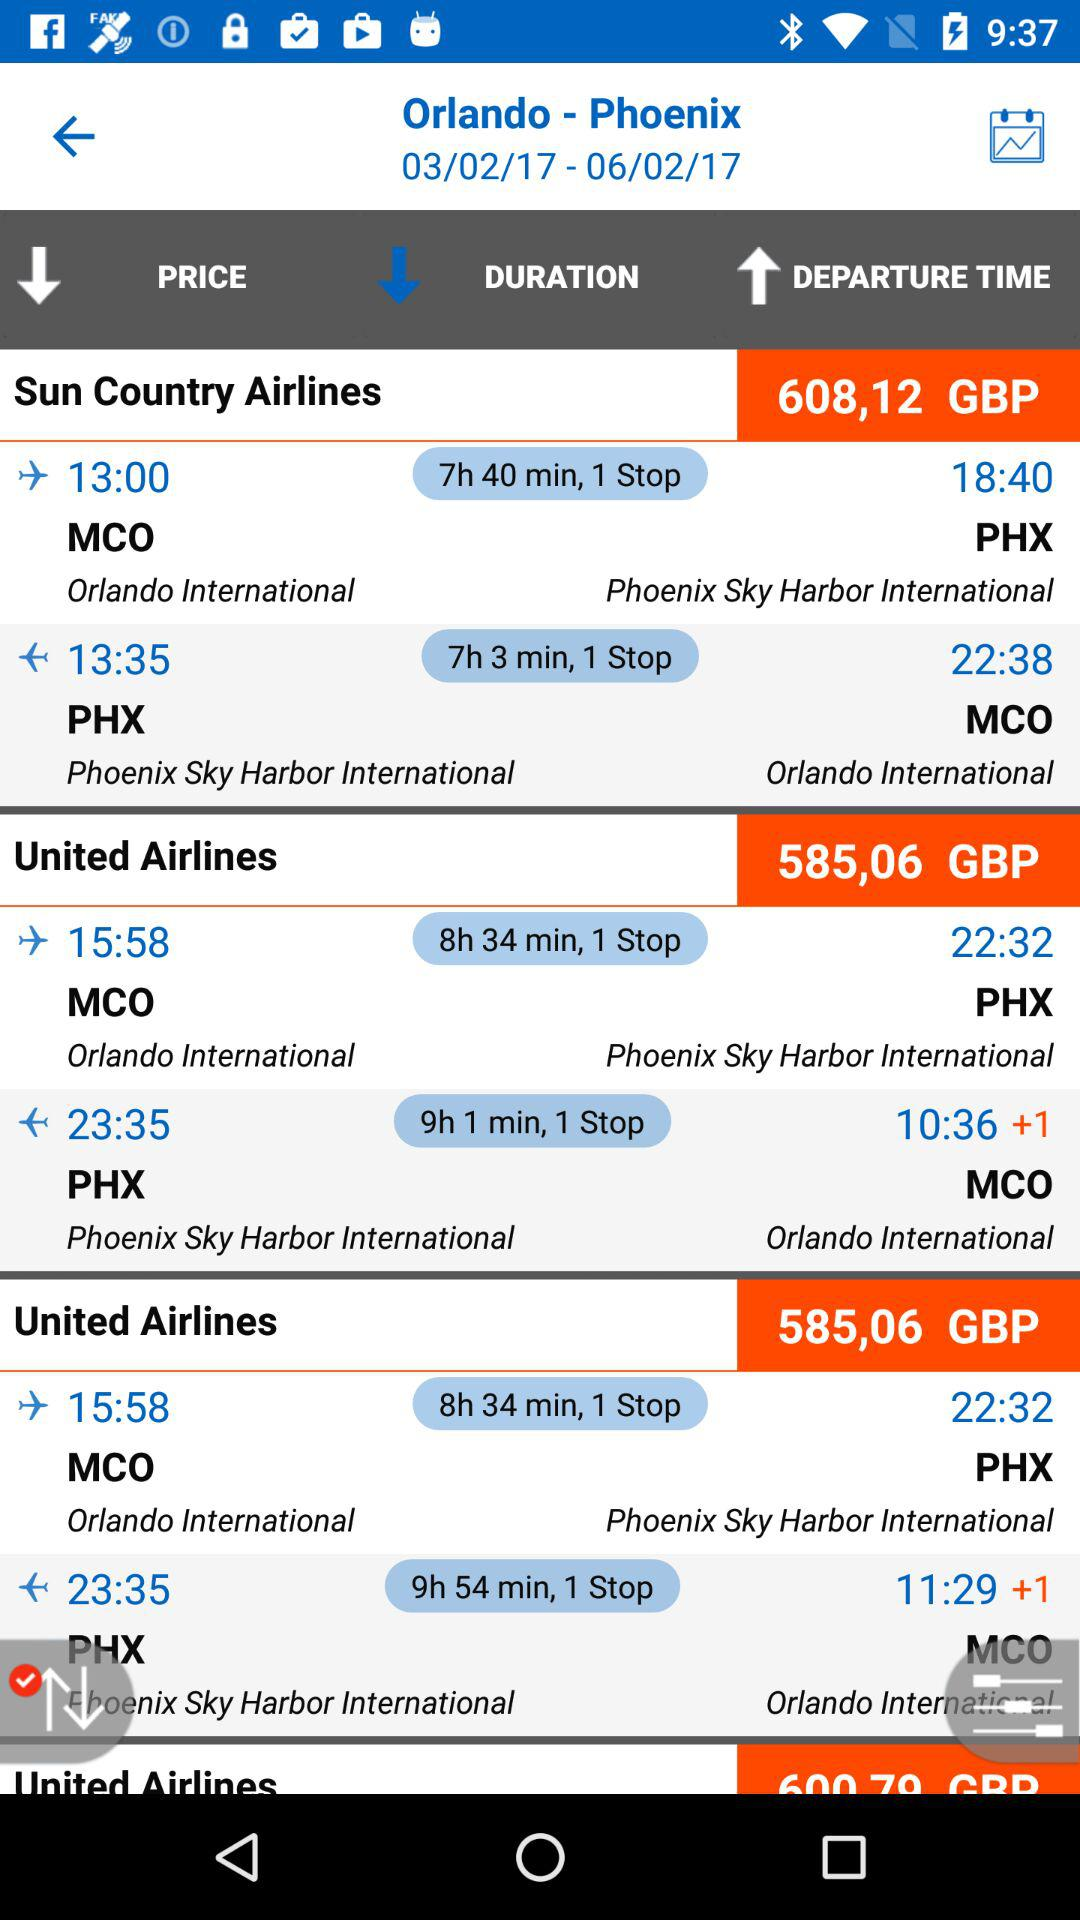Which airline has the longest flight duration?
Answer the question using a single word or phrase. United Airlines 